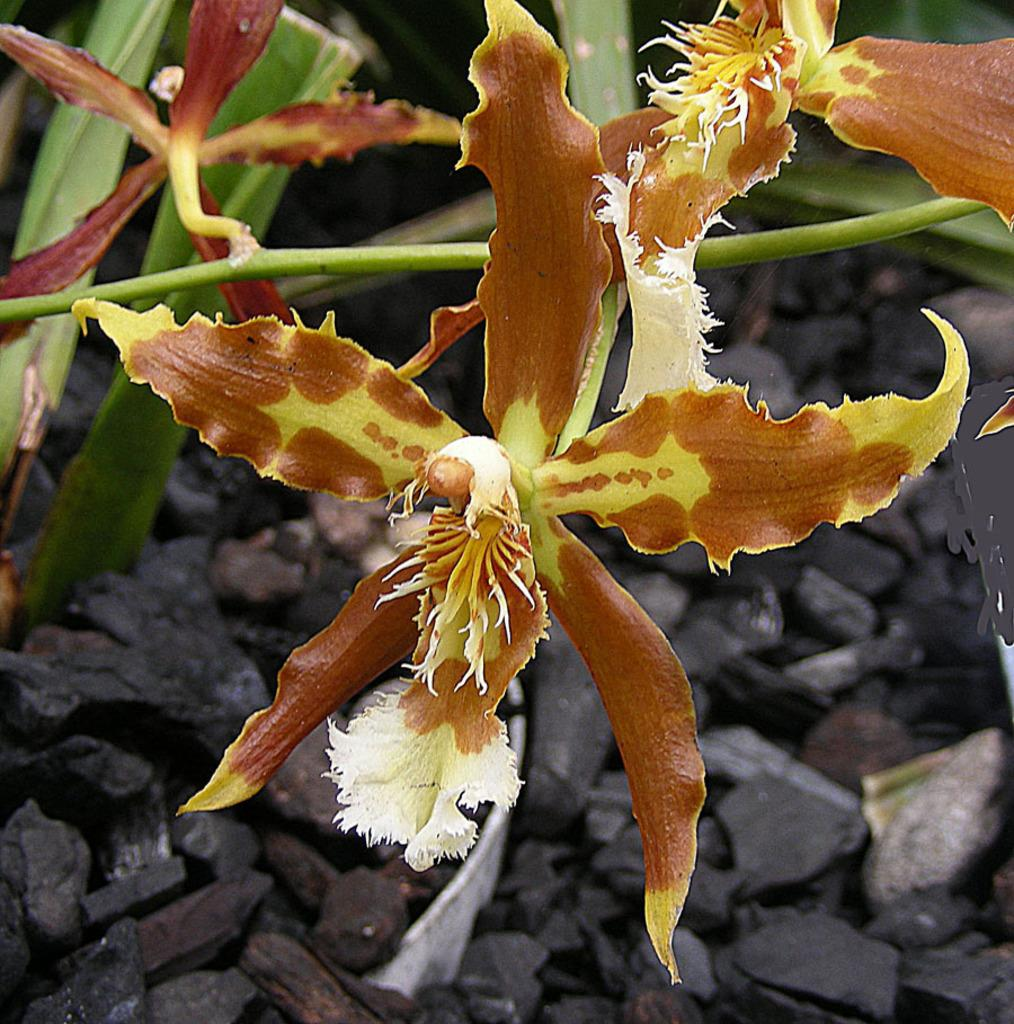What type of living organisms can be seen in the image? There are flowers in the image, which are associated with plants. What is the ground made of under the flowers? There are stones under the flowers. What type of flock can be seen flying over the flowers at night in the image? There is no flock or nighttime setting depicted in the image; it features flowers and stones. 